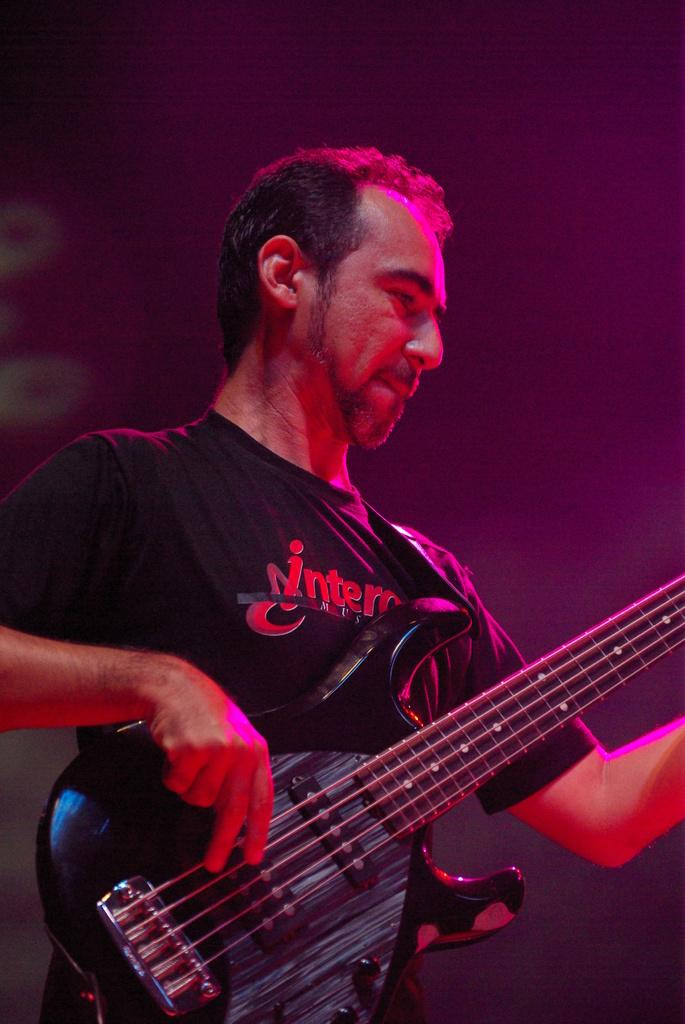Who is the main subject in the image? There is a man in the image. What is the man wearing? The man is wearing a black t-shirt. What object is the man holding in the image? The man is holding a guitar. What is the man doing with the guitar? The man is playing the guitar. How does the man's fear of the shade affect his performance in the image? There is no mention of fear or shade in the image, so it cannot be determined how they might affect the man's performance. 